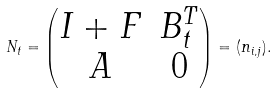<formula> <loc_0><loc_0><loc_500><loc_500>N _ { t } = \begin{pmatrix} I + F & B _ { t } ^ { T } \\ A & 0 \end{pmatrix} = ( n _ { i , j } ) .</formula> 